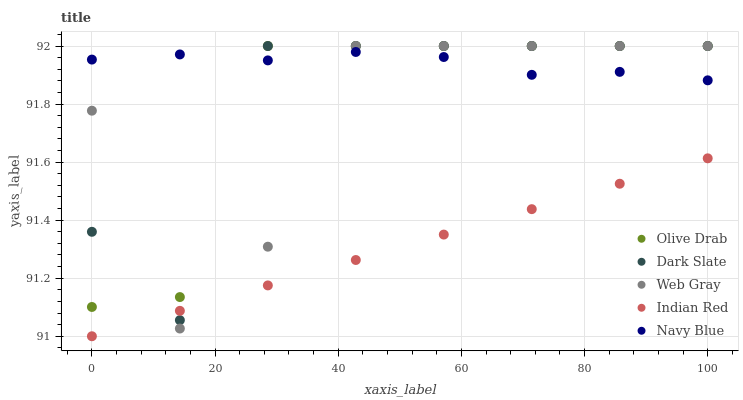Does Indian Red have the minimum area under the curve?
Answer yes or no. Yes. Does Navy Blue have the maximum area under the curve?
Answer yes or no. Yes. Does Web Gray have the minimum area under the curve?
Answer yes or no. No. Does Web Gray have the maximum area under the curve?
Answer yes or no. No. Is Indian Red the smoothest?
Answer yes or no. Yes. Is Dark Slate the roughest?
Answer yes or no. Yes. Is Web Gray the smoothest?
Answer yes or no. No. Is Web Gray the roughest?
Answer yes or no. No. Does Indian Red have the lowest value?
Answer yes or no. Yes. Does Web Gray have the lowest value?
Answer yes or no. No. Does Olive Drab have the highest value?
Answer yes or no. Yes. Does Indian Red have the highest value?
Answer yes or no. No. Is Indian Red less than Olive Drab?
Answer yes or no. Yes. Is Olive Drab greater than Indian Red?
Answer yes or no. Yes. Does Olive Drab intersect Navy Blue?
Answer yes or no. Yes. Is Olive Drab less than Navy Blue?
Answer yes or no. No. Is Olive Drab greater than Navy Blue?
Answer yes or no. No. Does Indian Red intersect Olive Drab?
Answer yes or no. No. 